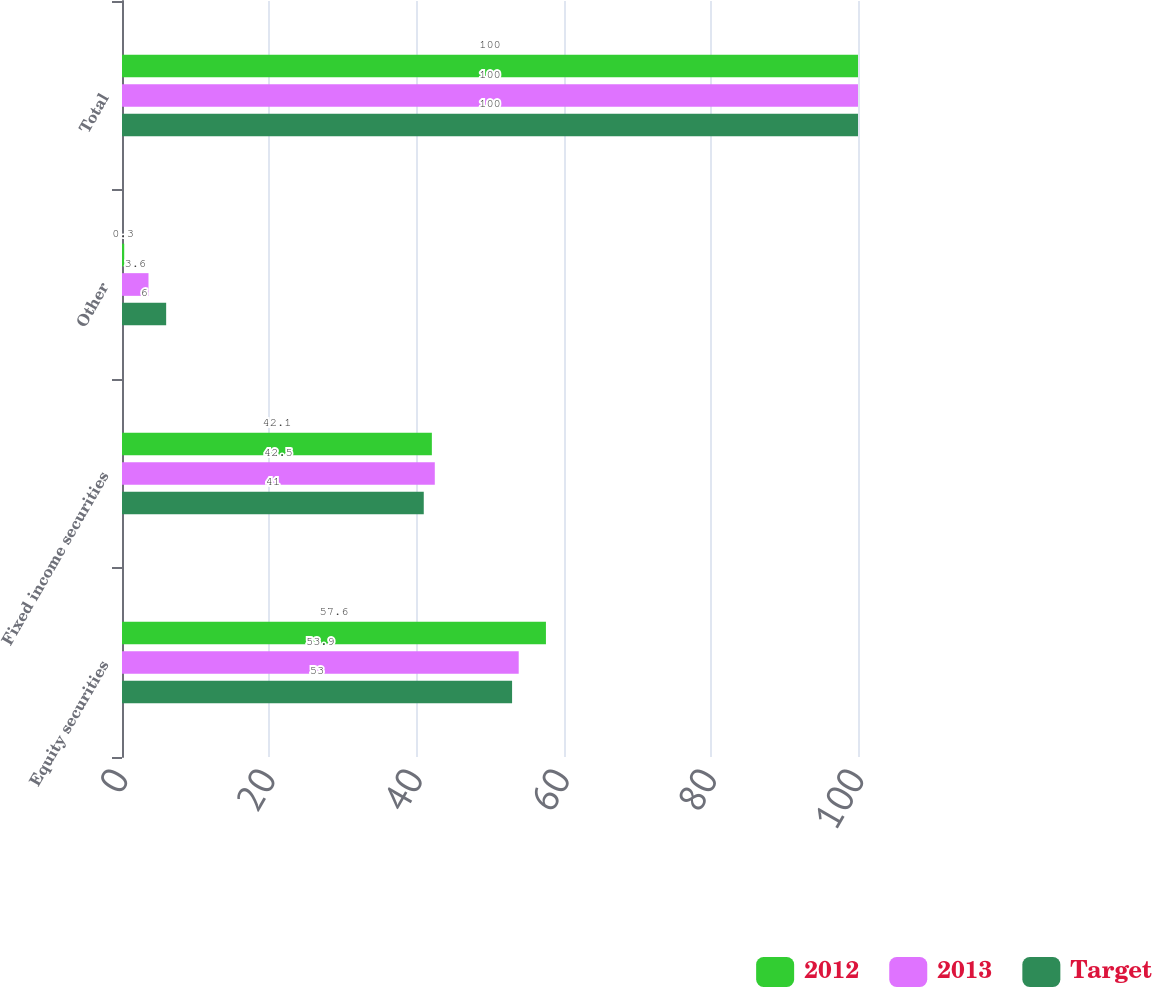<chart> <loc_0><loc_0><loc_500><loc_500><stacked_bar_chart><ecel><fcel>Equity securities<fcel>Fixed income securities<fcel>Other<fcel>Total<nl><fcel>2012<fcel>57.6<fcel>42.1<fcel>0.3<fcel>100<nl><fcel>2013<fcel>53.9<fcel>42.5<fcel>3.6<fcel>100<nl><fcel>Target<fcel>53<fcel>41<fcel>6<fcel>100<nl></chart> 